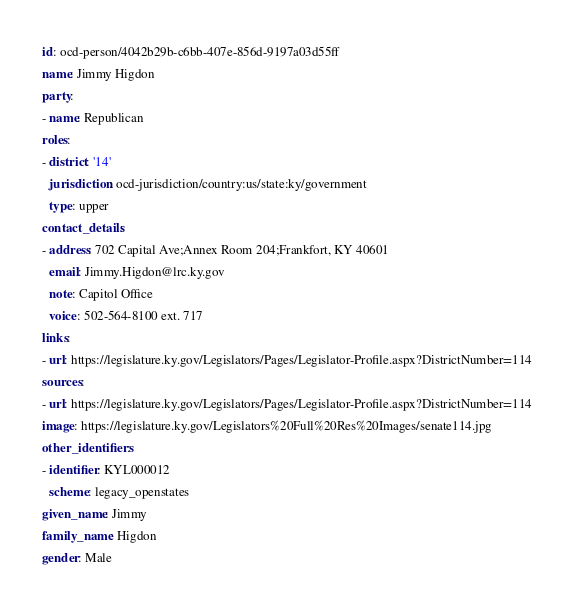<code> <loc_0><loc_0><loc_500><loc_500><_YAML_>id: ocd-person/4042b29b-c6bb-407e-856d-9197a03d55ff
name: Jimmy Higdon
party:
- name: Republican
roles:
- district: '14'
  jurisdiction: ocd-jurisdiction/country:us/state:ky/government
  type: upper
contact_details:
- address: 702 Capital Ave;Annex Room 204;Frankfort, KY 40601
  email: Jimmy.Higdon@lrc.ky.gov
  note: Capitol Office
  voice: 502-564-8100 ext. 717
links:
- url: https://legislature.ky.gov/Legislators/Pages/Legislator-Profile.aspx?DistrictNumber=114
sources:
- url: https://legislature.ky.gov/Legislators/Pages/Legislator-Profile.aspx?DistrictNumber=114
image: https://legislature.ky.gov/Legislators%20Full%20Res%20Images/senate114.jpg
other_identifiers:
- identifier: KYL000012
  scheme: legacy_openstates
given_name: Jimmy
family_name: Higdon
gender: Male
</code> 